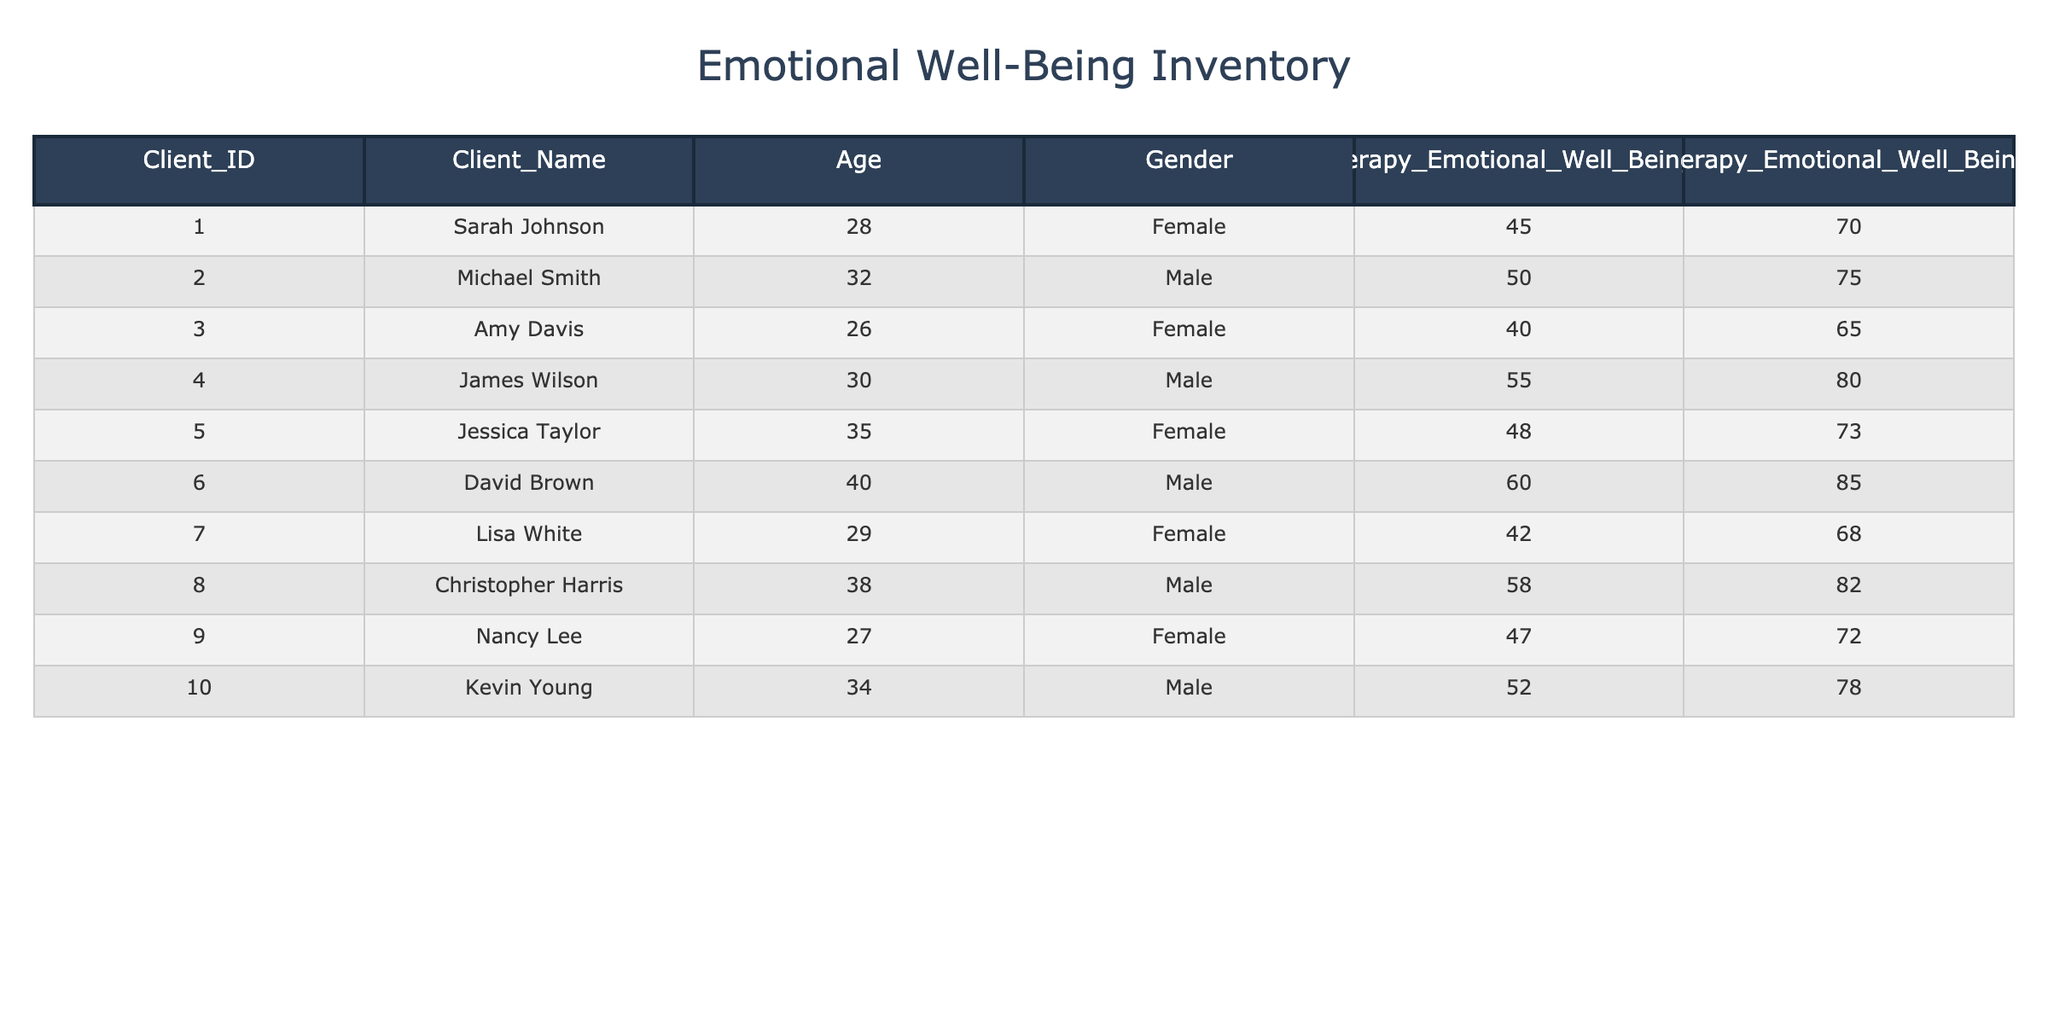What is Sarah Johnson's pre-therapy emotional well-being score? Looking at the row for Sarah Johnson in the table, the pre-therapy emotional well-being score listed is 45. This is directly referable from her corresponding data.
Answer: 45 What is the highest post-therapy emotional well-being score in the table? To determine the highest post-therapy emotional well-being score, I compared all post-therapy scores in the table. The maximum score identified is 85 associated with David Brown.
Answer: 85 How much did Jessica Taylor's emotional well-being score improve after therapy? Jessica Taylor's pre-therapy emotional well-being score is 48, and her post-therapy score is 73. The improvement is calculated by subtracting the pre-therapy score from the post-therapy score: 73 - 48 = 25.
Answer: 25 Is there a client who achieved the same emotional well-being score before and after therapy? By reviewing the scores in both the pre-therapy and post-therapy columns, I can see that no client has the same score in both instances. Each post-therapy score is higher than the pre-therapy score for all clients.
Answer: No What is the average pre-therapy emotional well-being score for all clients? First, I sum all the pre-therapy scores: 45 + 50 + 40 + 55 + 48 + 60 + 42 + 58 + 47 + 52 =  447. There are 10 clients, so I calculate the average by dividing the sum by the number of clients: 447 / 10 = 44.7.
Answer: 44.7 Which gender had a higher average post-therapy emotional well-being score? Calculating the average for females (70 + 65 + 73 + 68 + 72 = 348, divided by 5 gives 69.6), and for males (75 + 80 + 85 + 82 + 78 = 400, divided by 5 gives 80). Comparing the two averages, males have the higher average post-therapy score of 80.
Answer: Male How many clients improved their emotional well-being score by more than 20 points? Reviewing each client's improvement, I find that James Wilson (25), David Brown (25), and Christopher Harris (24) each improved by more than 20 points, resulting in a total of three clients.
Answer: 3 What was Amy Davis's post-therapy emotional well-being score relative to the average of all clients? Amy Davis's post-therapy score is 65. First, I find the average post-therapy score: 70 + 75 + 65 + 80 + 73 + 85 + 68 + 82 + 72 + 78 = 78. The comparison indicates that Amy's score is below the average of 78.
Answer: Below average 